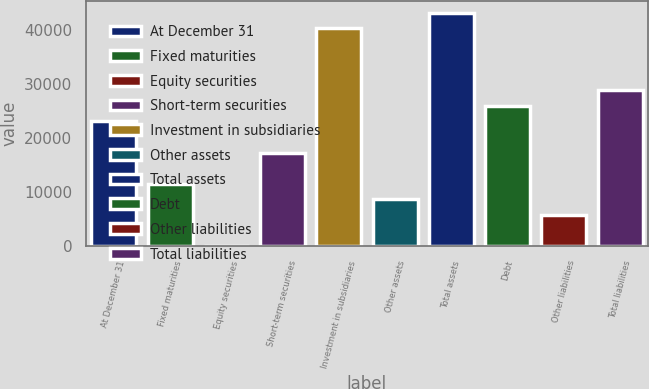Convert chart to OTSL. <chart><loc_0><loc_0><loc_500><loc_500><bar_chart><fcel>At December 31<fcel>Fixed maturities<fcel>Equity securities<fcel>Short-term securities<fcel>Investment in subsidiaries<fcel>Other assets<fcel>Total assets<fcel>Debt<fcel>Other liabilities<fcel>Total liabilities<nl><fcel>23071.8<fcel>11569.4<fcel>67<fcel>17320.6<fcel>40325.4<fcel>8693.8<fcel>43201<fcel>25947.4<fcel>5818.2<fcel>28823<nl></chart> 